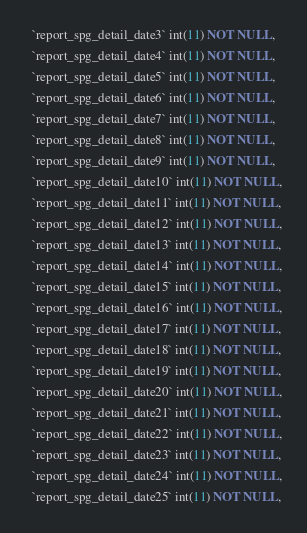Convert code to text. <code><loc_0><loc_0><loc_500><loc_500><_SQL_>  `report_spg_detail_date3` int(11) NOT NULL,
  `report_spg_detail_date4` int(11) NOT NULL,
  `report_spg_detail_date5` int(11) NOT NULL,
  `report_spg_detail_date6` int(11) NOT NULL,
  `report_spg_detail_date7` int(11) NOT NULL,
  `report_spg_detail_date8` int(11) NOT NULL,
  `report_spg_detail_date9` int(11) NOT NULL,
  `report_spg_detail_date10` int(11) NOT NULL,
  `report_spg_detail_date11` int(11) NOT NULL,
  `report_spg_detail_date12` int(11) NOT NULL,
  `report_spg_detail_date13` int(11) NOT NULL,
  `report_spg_detail_date14` int(11) NOT NULL,
  `report_spg_detail_date15` int(11) NOT NULL,
  `report_spg_detail_date16` int(11) NOT NULL,
  `report_spg_detail_date17` int(11) NOT NULL,
  `report_spg_detail_date18` int(11) NOT NULL,
  `report_spg_detail_date19` int(11) NOT NULL,
  `report_spg_detail_date20` int(11) NOT NULL,
  `report_spg_detail_date21` int(11) NOT NULL,
  `report_spg_detail_date22` int(11) NOT NULL,
  `report_spg_detail_date23` int(11) NOT NULL,
  `report_spg_detail_date24` int(11) NOT NULL,
  `report_spg_detail_date25` int(11) NOT NULL,</code> 